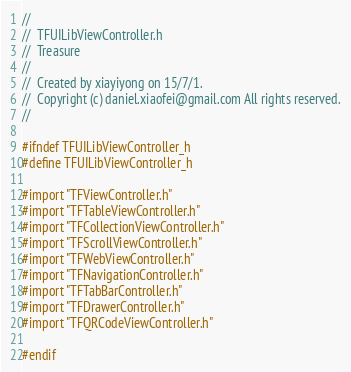Convert code to text. <code><loc_0><loc_0><loc_500><loc_500><_C_>//
//  TFUILibViewController.h
//  Treasure
//
//  Created by xiayiyong on 15/7/1.
//  Copyright (c) daniel.xiaofei@gmail.com All rights reserved.
//

#ifndef TFUILibViewController_h
#define TFUILibViewController_h

#import "TFViewController.h"
#import "TFTableViewController.h"
#import "TFCollectionViewController.h"
#import "TFScrollViewController.h"
#import "TFWebViewController.h"
#import "TFNavigationController.h"
#import "TFTabBarController.h"
#import "TFDrawerController.h"
#import "TFQRCodeViewController.h"

#endif
</code> 